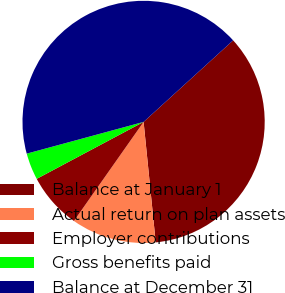<chart> <loc_0><loc_0><loc_500><loc_500><pie_chart><fcel>Balance at January 1<fcel>Actual return on plan assets<fcel>Employer contributions<fcel>Gross benefits paid<fcel>Balance at December 31<nl><fcel>35.17%<fcel>11.35%<fcel>7.46%<fcel>3.57%<fcel>42.47%<nl></chart> 